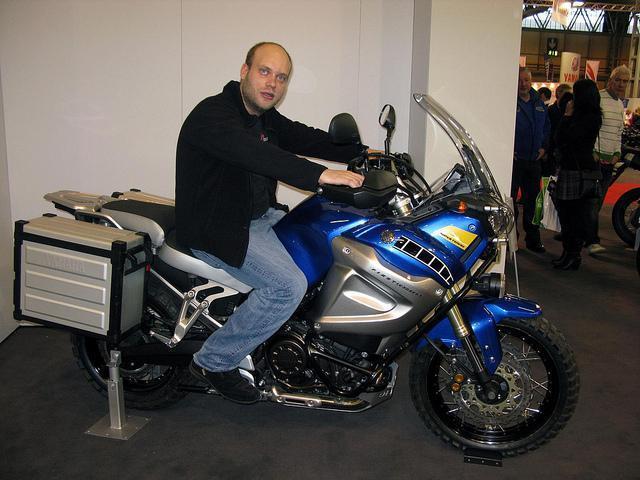How many people are in the picture?
Give a very brief answer. 4. How many hook and ladder fire trucks are there?
Give a very brief answer. 0. 